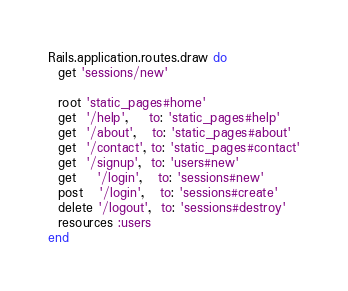Convert code to text. <code><loc_0><loc_0><loc_500><loc_500><_Ruby_>Rails.application.routes.draw do
  get 'sessions/new'

  root 'static_pages#home'
  get  '/help',    to: 'static_pages#help'
  get  '/about',   to: 'static_pages#about'
  get  '/contact', to: 'static_pages#contact'
  get  '/signup',  to: 'users#new'
  get    '/login',   to: 'sessions#new'
  post   '/login',   to: 'sessions#create'
  delete '/logout',  to: 'sessions#destroy'
  resources :users
end</code> 